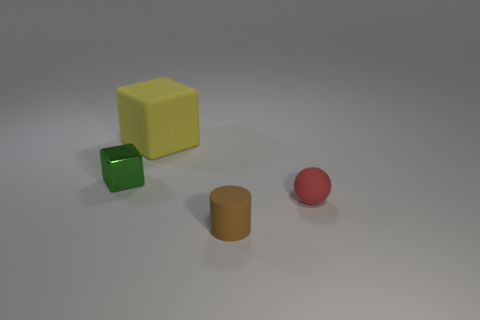What number of big red things are made of the same material as the yellow cube?
Provide a short and direct response. 0. What number of shiny objects are small brown objects or small green blocks?
Offer a very short reply. 1. There is a matte thing that is behind the green metal cube; does it have the same shape as the object that is in front of the tiny sphere?
Ensure brevity in your answer.  No. There is a small thing that is both in front of the metal thing and to the left of the tiny red rubber thing; what is its color?
Provide a succinct answer. Brown. There is a cube behind the tiny green block; is its size the same as the object in front of the ball?
Keep it short and to the point. No. How many tiny things have the same color as the metal block?
Your response must be concise. 0. What number of tiny things are either red rubber objects or brown shiny cubes?
Provide a short and direct response. 1. Are the small thing that is to the left of the large yellow matte object and the yellow thing made of the same material?
Provide a succinct answer. No. There is a cube that is to the left of the large object; what color is it?
Your response must be concise. Green. Is the number of tiny green rubber things the same as the number of small red spheres?
Ensure brevity in your answer.  No. 